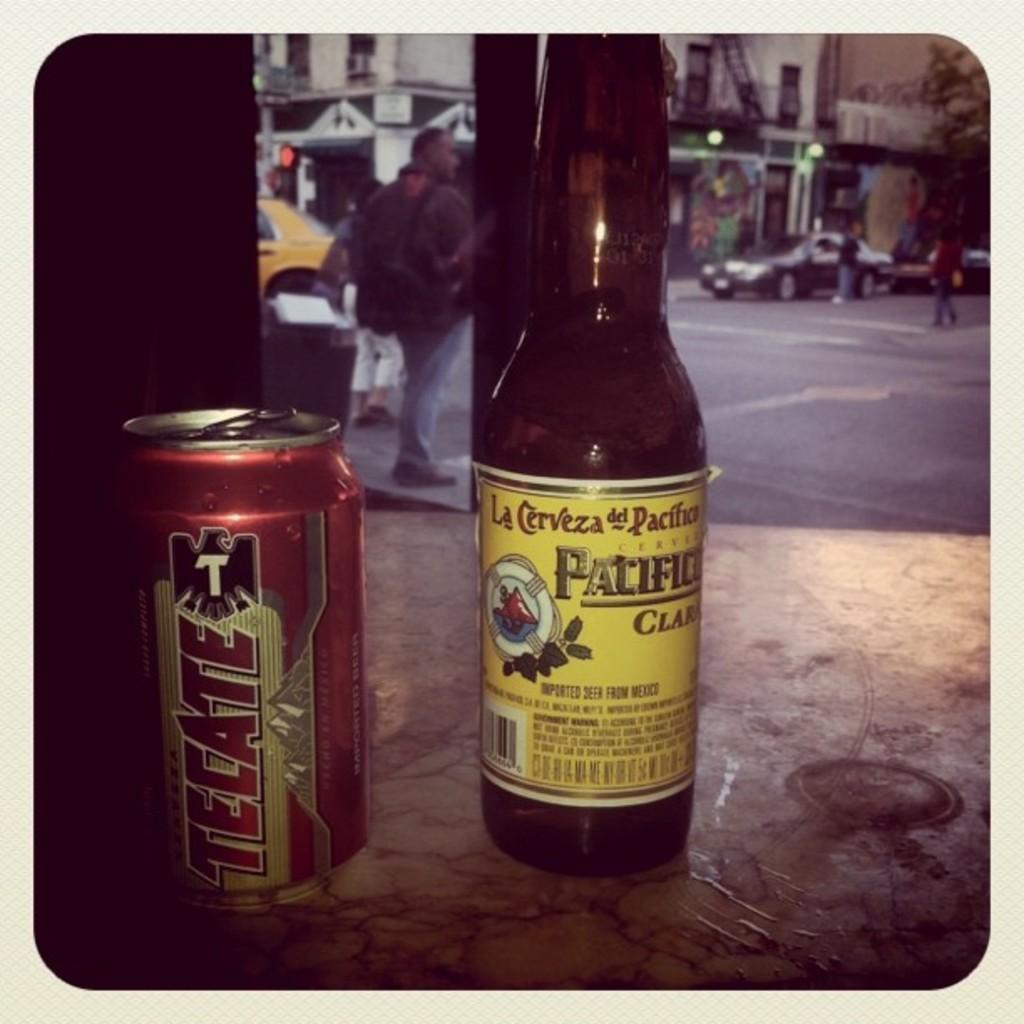<image>
Relay a brief, clear account of the picture shown. A can of beer called tecate sits next to a bottle of Pacifico. 